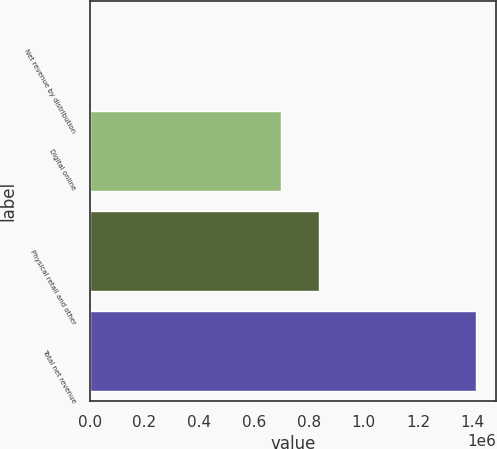Convert chart to OTSL. <chart><loc_0><loc_0><loc_500><loc_500><bar_chart><fcel>Net revenue by distribution<fcel>Digital online<fcel>Physical retail and other<fcel>Total net revenue<nl><fcel>2016<fcel>697658<fcel>838826<fcel>1.4137e+06<nl></chart> 